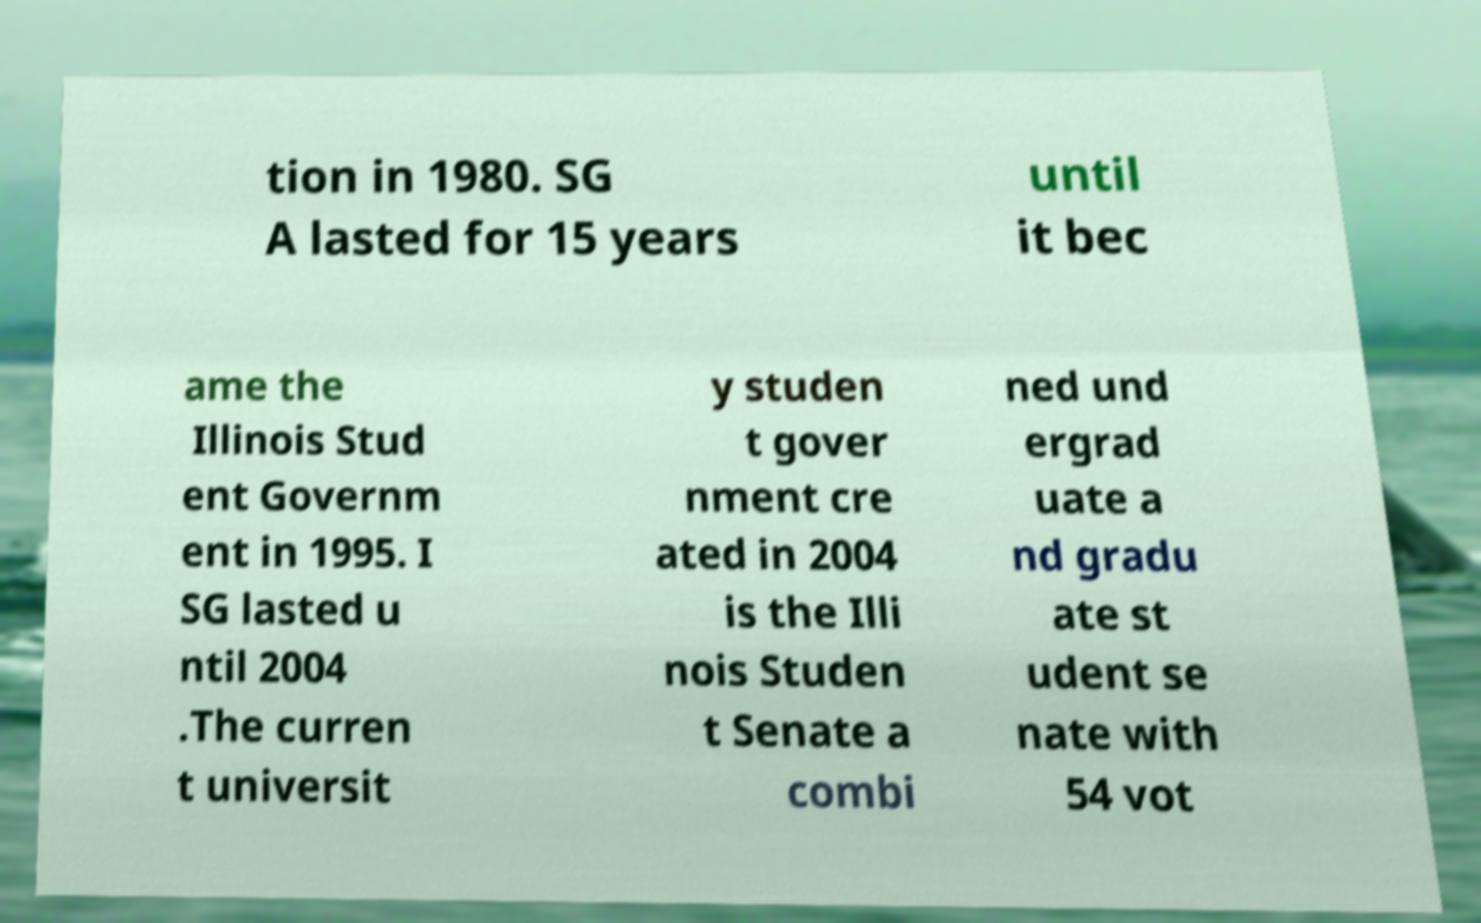There's text embedded in this image that I need extracted. Can you transcribe it verbatim? tion in 1980. SG A lasted for 15 years until it bec ame the Illinois Stud ent Governm ent in 1995. I SG lasted u ntil 2004 .The curren t universit y studen t gover nment cre ated in 2004 is the Illi nois Studen t Senate a combi ned und ergrad uate a nd gradu ate st udent se nate with 54 vot 